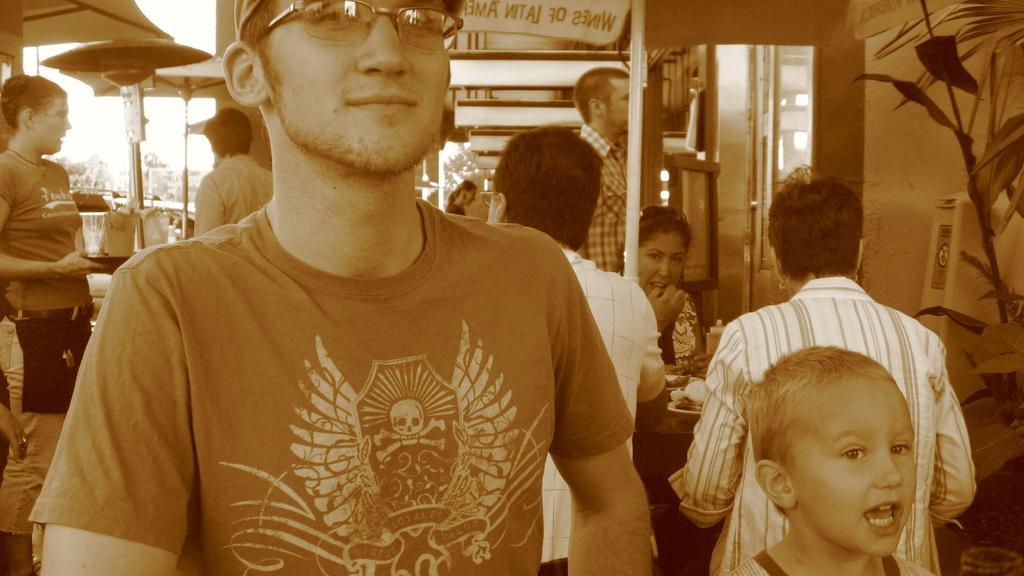Describe this image in one or two sentences. In this picture we can see a man wore spectacles and smiling and at the back of him we can see some people, umbrellas, leaves and some objects. 